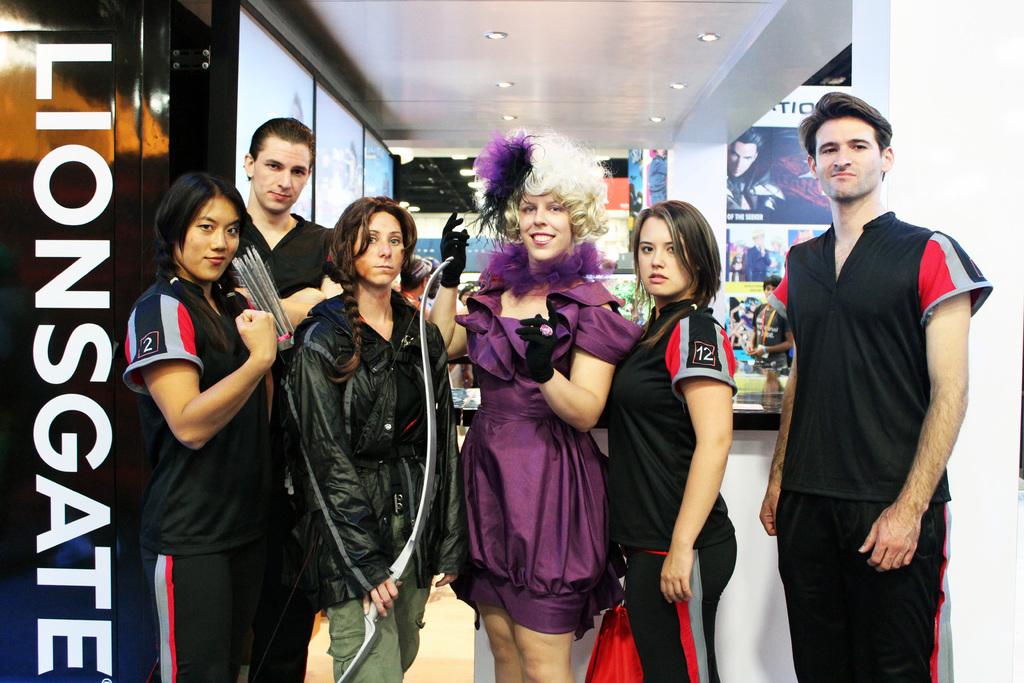What is the name of the company?
Provide a succinct answer. Lionsgate. What number is on the girls sleeve on the very left?
Your response must be concise. 2. 